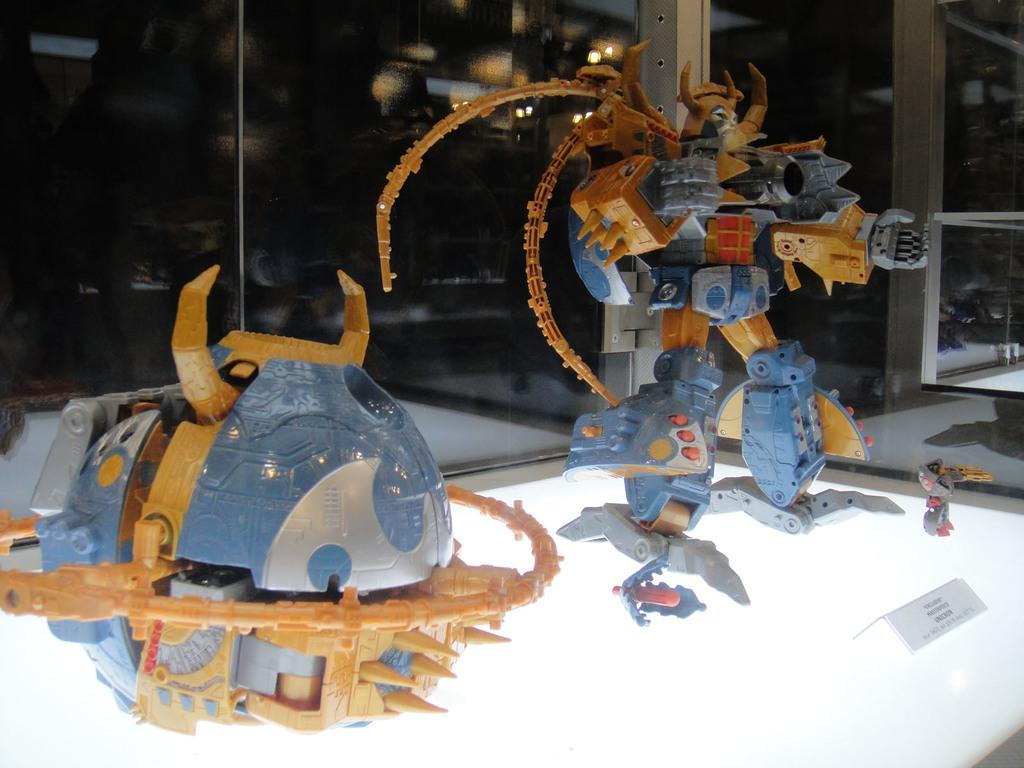What is placed on the white platform in the image? There are toys on a white platform in the image. What else can be seen on the white platform? There is a board on the white platform. What type of material is the glass element made of? The glass element is made of glass. What can be observed through the glass element? Lights are visible through the glass. Reasoning: Let's think step by step by step in order to produce the conversation. We start by identifying the main subjects and objects in the image based on the provided facts. We then formulate questions that focus on the location and characteristics of these subjects and objects, ensuring that each question can be answered definitively with the information given. We avoid yes/no questions and ensure that the language is simple and clear. Absurd Question/Answer: How many lizards are crawling on the board in the image? There are no lizards present in the image. What color is the curtain behind the toys in the image? There is no curtain present in the image. What type of cat can be seen playing with the toys on the white platform in the image? There is no cat present in the image. What color is the curtain behind the toys in the image? There is no curtain present in the image. 